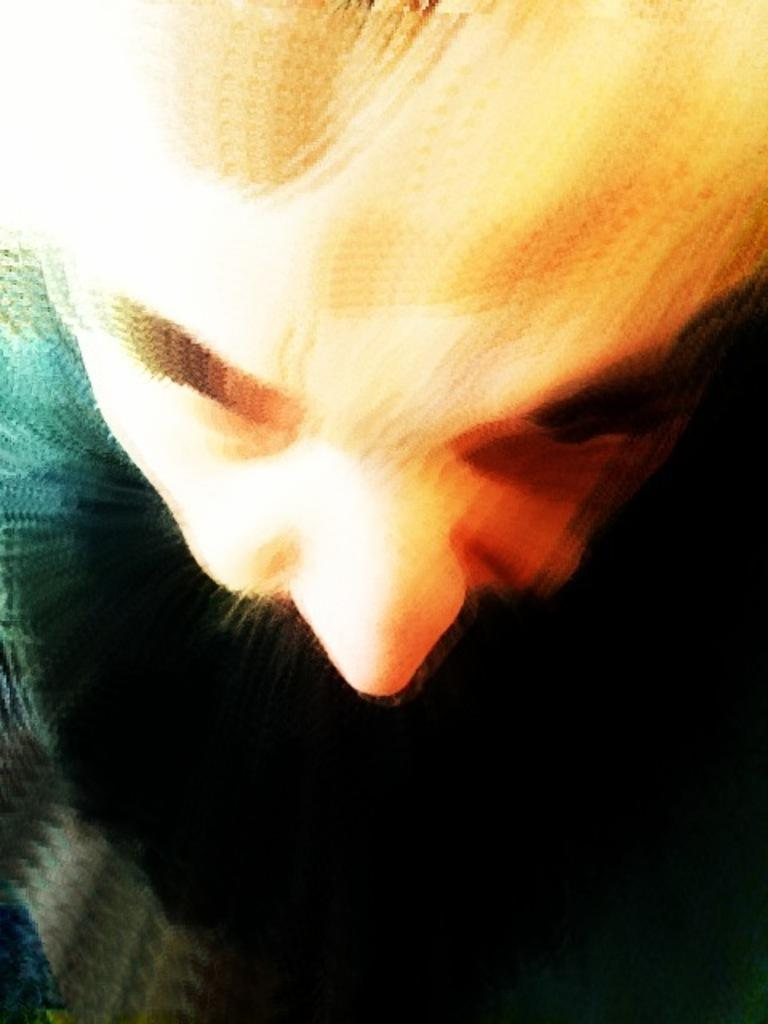What is the main subject of the image? There is a person in the image. Can you describe the quality of the image? The image is blurred. What type of memory is being used by the person in the image? There is no information about the person's memory in the image, as it is not visible or mentioned in the provided facts. 